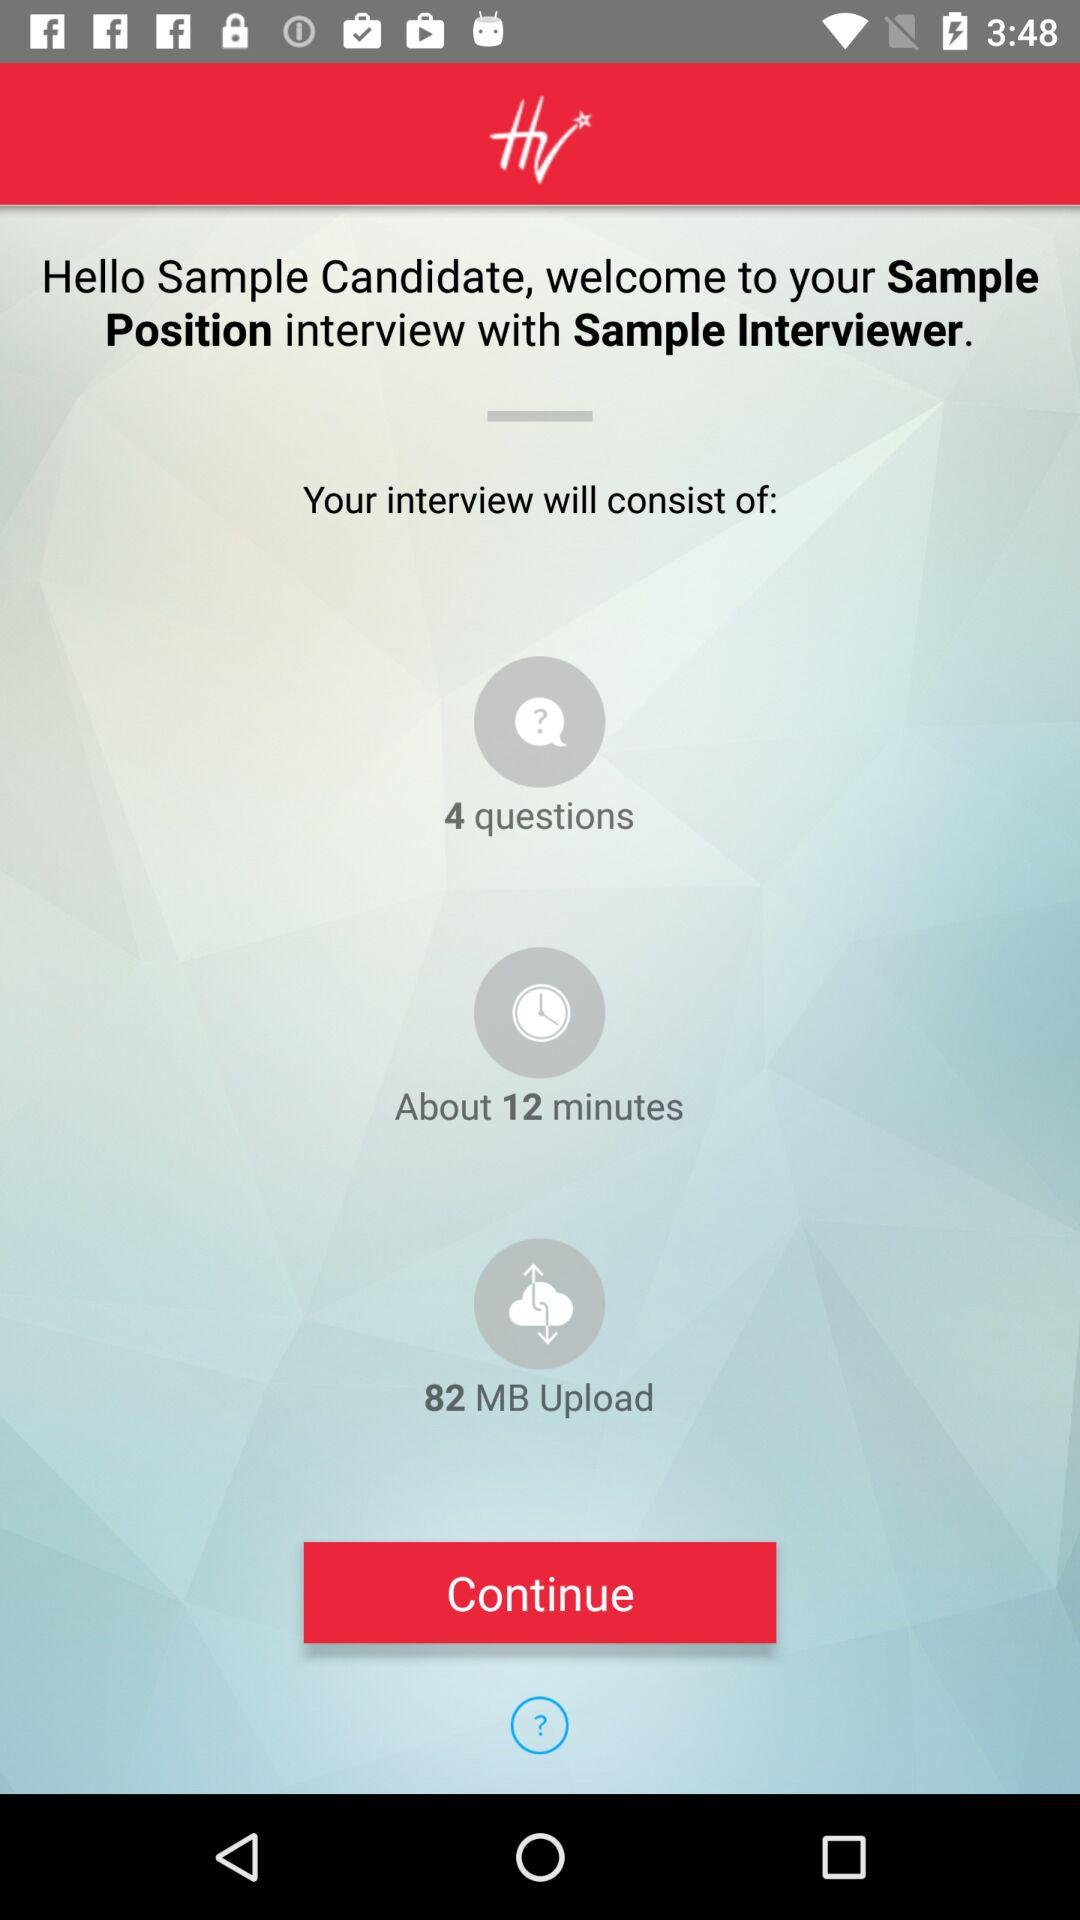How many MB is the upload?
Answer the question using a single word or phrase. 82 